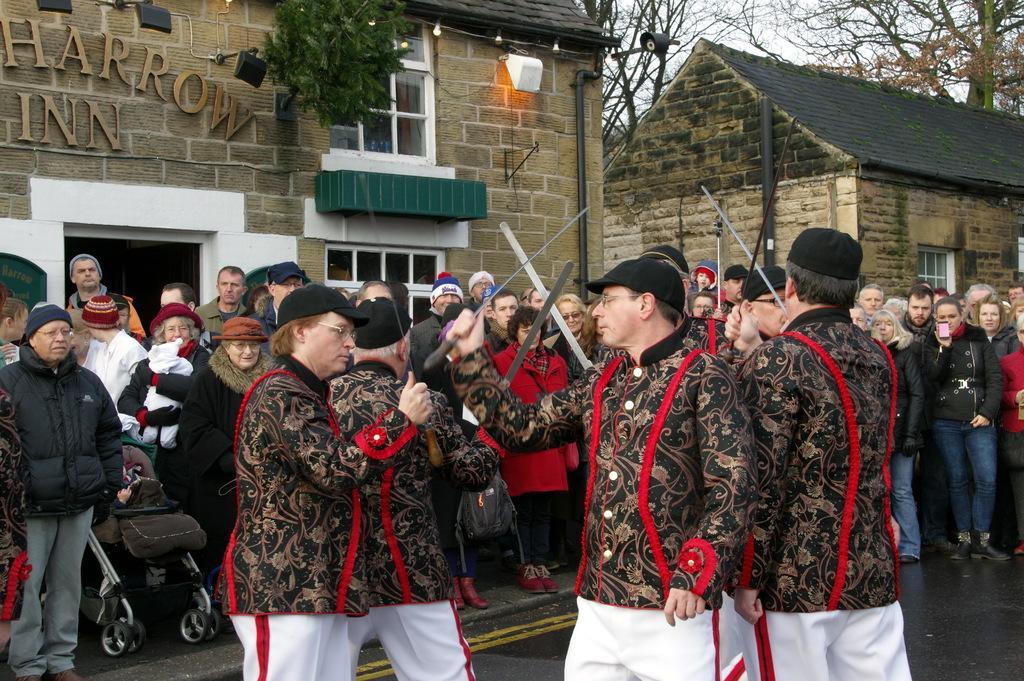Please provide a concise description of this image. In this picture we can see buildings, in front we can see so many people among them we can see some are holding knife. 